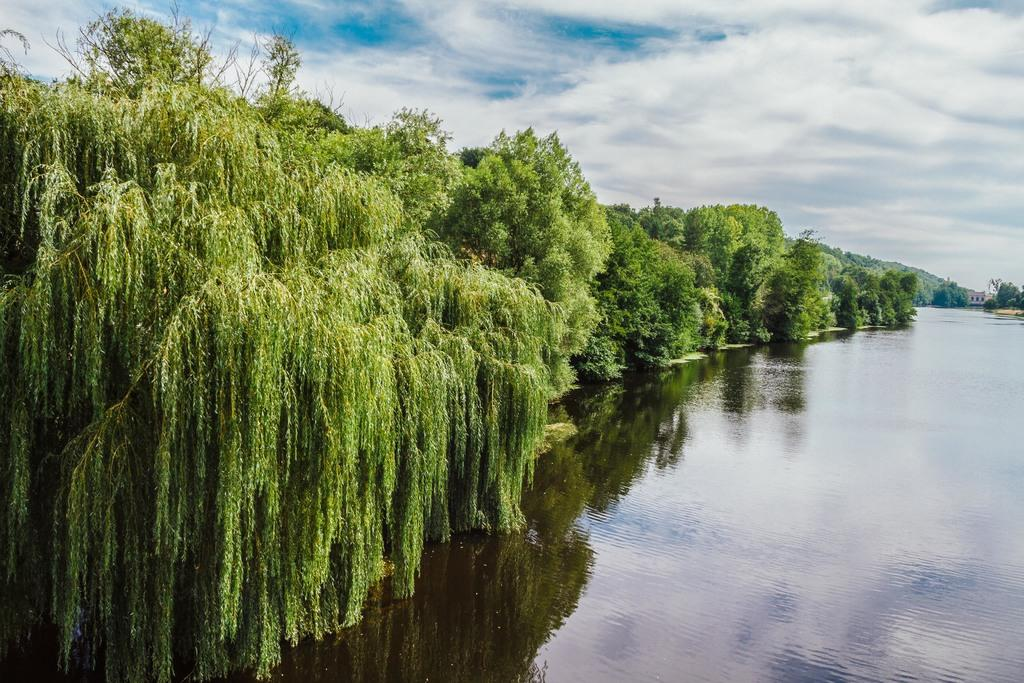What type of vegetation is visible in the image? There are trees in the image. What is visible at the bottom of the image? There is water visible at the bottom of the image. What part of the natural environment is visible in the background of the image? The sky is visible in the background of the image. How many fingers can be seen in the image? There are no fingers visible in the image. What type of observation can be made about the water in the image? The water in the image is not the main focus of the conversation, as the facts provided do not mention any specific details about the water. 